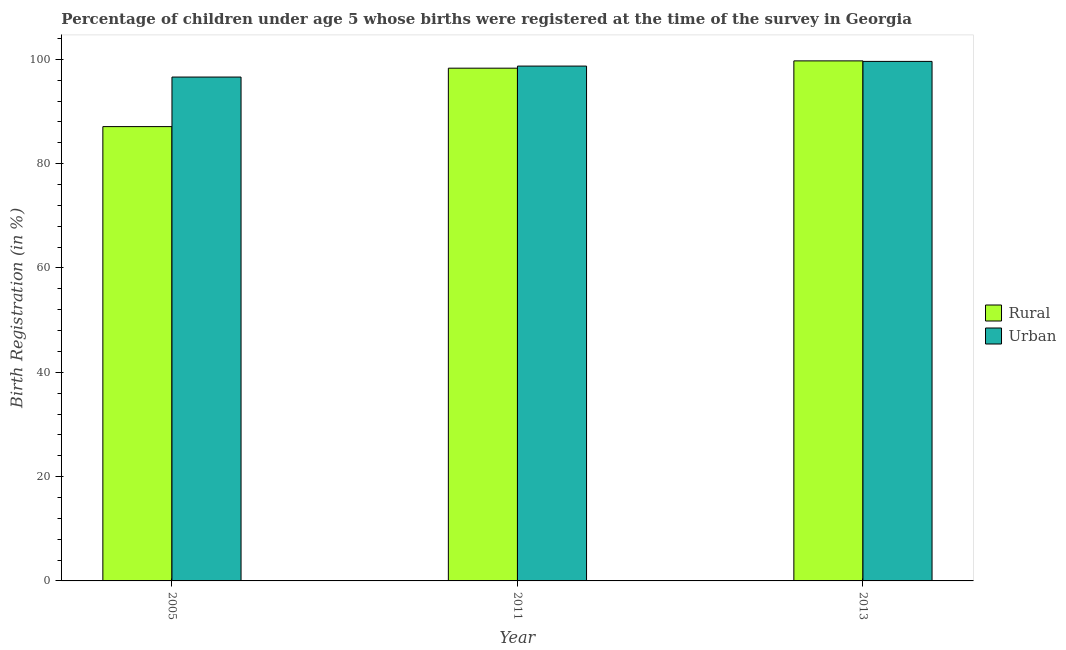How many different coloured bars are there?
Keep it short and to the point. 2. Are the number of bars on each tick of the X-axis equal?
Provide a succinct answer. Yes. How many bars are there on the 3rd tick from the left?
Offer a very short reply. 2. In how many cases, is the number of bars for a given year not equal to the number of legend labels?
Give a very brief answer. 0. What is the urban birth registration in 2005?
Ensure brevity in your answer.  96.6. Across all years, what is the maximum rural birth registration?
Offer a very short reply. 99.7. Across all years, what is the minimum rural birth registration?
Provide a succinct answer. 87.1. What is the total rural birth registration in the graph?
Keep it short and to the point. 285.1. What is the difference between the rural birth registration in 2011 and that in 2013?
Give a very brief answer. -1.4. What is the difference between the rural birth registration in 2005 and the urban birth registration in 2011?
Your answer should be very brief. -11.2. What is the average rural birth registration per year?
Make the answer very short. 95.03. In the year 2013, what is the difference between the urban birth registration and rural birth registration?
Provide a succinct answer. 0. What is the ratio of the urban birth registration in 2011 to that in 2013?
Your response must be concise. 0.99. Is the difference between the urban birth registration in 2005 and 2013 greater than the difference between the rural birth registration in 2005 and 2013?
Make the answer very short. No. What is the difference between the highest and the second highest urban birth registration?
Offer a very short reply. 0.9. What is the difference between the highest and the lowest urban birth registration?
Give a very brief answer. 3. In how many years, is the urban birth registration greater than the average urban birth registration taken over all years?
Your response must be concise. 2. What does the 2nd bar from the left in 2005 represents?
Offer a very short reply. Urban. What does the 2nd bar from the right in 2013 represents?
Make the answer very short. Rural. How many years are there in the graph?
Your answer should be very brief. 3. Are the values on the major ticks of Y-axis written in scientific E-notation?
Your answer should be compact. No. Does the graph contain grids?
Ensure brevity in your answer.  No. How many legend labels are there?
Your answer should be compact. 2. What is the title of the graph?
Give a very brief answer. Percentage of children under age 5 whose births were registered at the time of the survey in Georgia. What is the label or title of the X-axis?
Your answer should be compact. Year. What is the label or title of the Y-axis?
Your answer should be very brief. Birth Registration (in %). What is the Birth Registration (in %) of Rural in 2005?
Your answer should be very brief. 87.1. What is the Birth Registration (in %) in Urban in 2005?
Provide a succinct answer. 96.6. What is the Birth Registration (in %) of Rural in 2011?
Your answer should be compact. 98.3. What is the Birth Registration (in %) of Urban in 2011?
Offer a very short reply. 98.7. What is the Birth Registration (in %) in Rural in 2013?
Give a very brief answer. 99.7. What is the Birth Registration (in %) of Urban in 2013?
Your answer should be compact. 99.6. Across all years, what is the maximum Birth Registration (in %) in Rural?
Keep it short and to the point. 99.7. Across all years, what is the maximum Birth Registration (in %) in Urban?
Provide a succinct answer. 99.6. Across all years, what is the minimum Birth Registration (in %) in Rural?
Offer a terse response. 87.1. Across all years, what is the minimum Birth Registration (in %) in Urban?
Offer a terse response. 96.6. What is the total Birth Registration (in %) of Rural in the graph?
Provide a short and direct response. 285.1. What is the total Birth Registration (in %) of Urban in the graph?
Ensure brevity in your answer.  294.9. What is the difference between the Birth Registration (in %) in Urban in 2005 and that in 2011?
Your answer should be compact. -2.1. What is the difference between the Birth Registration (in %) in Urban in 2005 and that in 2013?
Make the answer very short. -3. What is the difference between the Birth Registration (in %) in Rural in 2011 and that in 2013?
Give a very brief answer. -1.4. What is the difference between the Birth Registration (in %) of Rural in 2005 and the Birth Registration (in %) of Urban in 2013?
Your answer should be compact. -12.5. What is the average Birth Registration (in %) of Rural per year?
Provide a short and direct response. 95.03. What is the average Birth Registration (in %) in Urban per year?
Your answer should be compact. 98.3. In the year 2011, what is the difference between the Birth Registration (in %) of Rural and Birth Registration (in %) of Urban?
Offer a very short reply. -0.4. In the year 2013, what is the difference between the Birth Registration (in %) in Rural and Birth Registration (in %) in Urban?
Your answer should be compact. 0.1. What is the ratio of the Birth Registration (in %) of Rural in 2005 to that in 2011?
Make the answer very short. 0.89. What is the ratio of the Birth Registration (in %) in Urban in 2005 to that in 2011?
Your response must be concise. 0.98. What is the ratio of the Birth Registration (in %) of Rural in 2005 to that in 2013?
Your response must be concise. 0.87. What is the ratio of the Birth Registration (in %) in Urban in 2005 to that in 2013?
Your answer should be compact. 0.97. What is the ratio of the Birth Registration (in %) in Urban in 2011 to that in 2013?
Your answer should be very brief. 0.99. What is the difference between the highest and the second highest Birth Registration (in %) of Urban?
Your response must be concise. 0.9. 